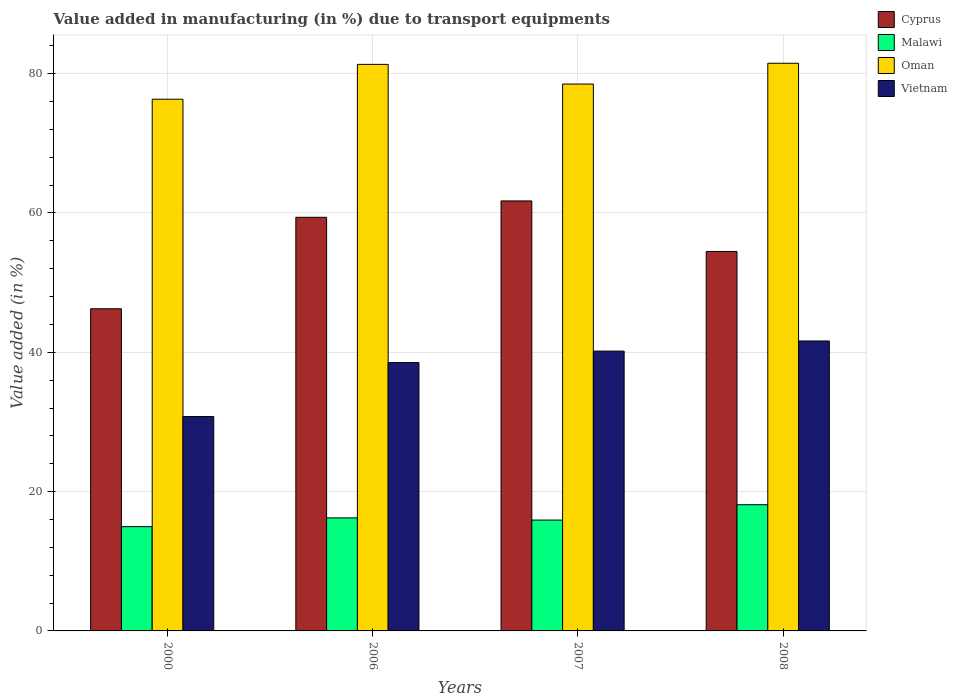Are the number of bars per tick equal to the number of legend labels?
Provide a succinct answer. Yes. How many bars are there on the 2nd tick from the left?
Keep it short and to the point. 4. How many bars are there on the 3rd tick from the right?
Make the answer very short. 4. What is the label of the 4th group of bars from the left?
Ensure brevity in your answer.  2008. In how many cases, is the number of bars for a given year not equal to the number of legend labels?
Make the answer very short. 0. What is the percentage of value added in manufacturing due to transport equipments in Vietnam in 2008?
Provide a succinct answer. 41.62. Across all years, what is the maximum percentage of value added in manufacturing due to transport equipments in Malawi?
Offer a very short reply. 18.12. Across all years, what is the minimum percentage of value added in manufacturing due to transport equipments in Malawi?
Give a very brief answer. 14.97. In which year was the percentage of value added in manufacturing due to transport equipments in Cyprus maximum?
Offer a terse response. 2007. What is the total percentage of value added in manufacturing due to transport equipments in Cyprus in the graph?
Make the answer very short. 221.82. What is the difference between the percentage of value added in manufacturing due to transport equipments in Vietnam in 2006 and that in 2007?
Make the answer very short. -1.65. What is the difference between the percentage of value added in manufacturing due to transport equipments in Malawi in 2000 and the percentage of value added in manufacturing due to transport equipments in Oman in 2008?
Keep it short and to the point. -66.52. What is the average percentage of value added in manufacturing due to transport equipments in Cyprus per year?
Make the answer very short. 55.46. In the year 2000, what is the difference between the percentage of value added in manufacturing due to transport equipments in Cyprus and percentage of value added in manufacturing due to transport equipments in Oman?
Ensure brevity in your answer.  -30.08. What is the ratio of the percentage of value added in manufacturing due to transport equipments in Malawi in 2006 to that in 2007?
Give a very brief answer. 1.02. What is the difference between the highest and the second highest percentage of value added in manufacturing due to transport equipments in Cyprus?
Offer a terse response. 2.35. What is the difference between the highest and the lowest percentage of value added in manufacturing due to transport equipments in Malawi?
Your answer should be very brief. 3.15. In how many years, is the percentage of value added in manufacturing due to transport equipments in Oman greater than the average percentage of value added in manufacturing due to transport equipments in Oman taken over all years?
Make the answer very short. 2. Is the sum of the percentage of value added in manufacturing due to transport equipments in Vietnam in 2007 and 2008 greater than the maximum percentage of value added in manufacturing due to transport equipments in Oman across all years?
Give a very brief answer. Yes. What does the 2nd bar from the left in 2006 represents?
Your response must be concise. Malawi. What does the 4th bar from the right in 2006 represents?
Offer a very short reply. Cyprus. How many years are there in the graph?
Offer a very short reply. 4. Where does the legend appear in the graph?
Ensure brevity in your answer.  Top right. How are the legend labels stacked?
Your response must be concise. Vertical. What is the title of the graph?
Provide a succinct answer. Value added in manufacturing (in %) due to transport equipments. What is the label or title of the X-axis?
Offer a very short reply. Years. What is the label or title of the Y-axis?
Provide a succinct answer. Value added (in %). What is the Value added (in %) in Cyprus in 2000?
Provide a short and direct response. 46.25. What is the Value added (in %) of Malawi in 2000?
Give a very brief answer. 14.97. What is the Value added (in %) of Oman in 2000?
Provide a short and direct response. 76.33. What is the Value added (in %) in Vietnam in 2000?
Give a very brief answer. 30.77. What is the Value added (in %) in Cyprus in 2006?
Give a very brief answer. 59.38. What is the Value added (in %) of Malawi in 2006?
Ensure brevity in your answer.  16.23. What is the Value added (in %) of Oman in 2006?
Keep it short and to the point. 81.33. What is the Value added (in %) in Vietnam in 2006?
Offer a very short reply. 38.52. What is the Value added (in %) of Cyprus in 2007?
Keep it short and to the point. 61.73. What is the Value added (in %) in Malawi in 2007?
Your response must be concise. 15.91. What is the Value added (in %) of Oman in 2007?
Your answer should be very brief. 78.51. What is the Value added (in %) in Vietnam in 2007?
Your response must be concise. 40.17. What is the Value added (in %) in Cyprus in 2008?
Your answer should be compact. 54.47. What is the Value added (in %) in Malawi in 2008?
Provide a succinct answer. 18.12. What is the Value added (in %) in Oman in 2008?
Make the answer very short. 81.49. What is the Value added (in %) in Vietnam in 2008?
Your answer should be compact. 41.62. Across all years, what is the maximum Value added (in %) of Cyprus?
Ensure brevity in your answer.  61.73. Across all years, what is the maximum Value added (in %) in Malawi?
Ensure brevity in your answer.  18.12. Across all years, what is the maximum Value added (in %) of Oman?
Offer a terse response. 81.49. Across all years, what is the maximum Value added (in %) of Vietnam?
Give a very brief answer. 41.62. Across all years, what is the minimum Value added (in %) of Cyprus?
Provide a succinct answer. 46.25. Across all years, what is the minimum Value added (in %) of Malawi?
Ensure brevity in your answer.  14.97. Across all years, what is the minimum Value added (in %) in Oman?
Your answer should be very brief. 76.33. Across all years, what is the minimum Value added (in %) of Vietnam?
Ensure brevity in your answer.  30.77. What is the total Value added (in %) of Cyprus in the graph?
Provide a short and direct response. 221.82. What is the total Value added (in %) in Malawi in the graph?
Ensure brevity in your answer.  65.23. What is the total Value added (in %) of Oman in the graph?
Make the answer very short. 317.66. What is the total Value added (in %) of Vietnam in the graph?
Make the answer very short. 151.09. What is the difference between the Value added (in %) in Cyprus in 2000 and that in 2006?
Give a very brief answer. -13.13. What is the difference between the Value added (in %) of Malawi in 2000 and that in 2006?
Give a very brief answer. -1.26. What is the difference between the Value added (in %) in Oman in 2000 and that in 2006?
Provide a succinct answer. -5. What is the difference between the Value added (in %) of Vietnam in 2000 and that in 2006?
Provide a short and direct response. -7.75. What is the difference between the Value added (in %) in Cyprus in 2000 and that in 2007?
Provide a short and direct response. -15.48. What is the difference between the Value added (in %) in Malawi in 2000 and that in 2007?
Provide a short and direct response. -0.94. What is the difference between the Value added (in %) of Oman in 2000 and that in 2007?
Give a very brief answer. -2.18. What is the difference between the Value added (in %) in Vietnam in 2000 and that in 2007?
Your answer should be very brief. -9.4. What is the difference between the Value added (in %) in Cyprus in 2000 and that in 2008?
Give a very brief answer. -8.22. What is the difference between the Value added (in %) in Malawi in 2000 and that in 2008?
Your answer should be compact. -3.15. What is the difference between the Value added (in %) in Oman in 2000 and that in 2008?
Give a very brief answer. -5.16. What is the difference between the Value added (in %) of Vietnam in 2000 and that in 2008?
Your answer should be very brief. -10.85. What is the difference between the Value added (in %) of Cyprus in 2006 and that in 2007?
Offer a terse response. -2.35. What is the difference between the Value added (in %) of Malawi in 2006 and that in 2007?
Offer a very short reply. 0.31. What is the difference between the Value added (in %) in Oman in 2006 and that in 2007?
Provide a succinct answer. 2.82. What is the difference between the Value added (in %) of Vietnam in 2006 and that in 2007?
Your answer should be compact. -1.65. What is the difference between the Value added (in %) of Cyprus in 2006 and that in 2008?
Provide a short and direct response. 4.91. What is the difference between the Value added (in %) of Malawi in 2006 and that in 2008?
Your answer should be compact. -1.89. What is the difference between the Value added (in %) of Oman in 2006 and that in 2008?
Ensure brevity in your answer.  -0.16. What is the difference between the Value added (in %) of Vietnam in 2006 and that in 2008?
Your answer should be very brief. -3.1. What is the difference between the Value added (in %) in Cyprus in 2007 and that in 2008?
Your response must be concise. 7.26. What is the difference between the Value added (in %) of Malawi in 2007 and that in 2008?
Provide a succinct answer. -2.2. What is the difference between the Value added (in %) of Oman in 2007 and that in 2008?
Offer a terse response. -2.98. What is the difference between the Value added (in %) of Vietnam in 2007 and that in 2008?
Offer a terse response. -1.45. What is the difference between the Value added (in %) in Cyprus in 2000 and the Value added (in %) in Malawi in 2006?
Your response must be concise. 30.02. What is the difference between the Value added (in %) of Cyprus in 2000 and the Value added (in %) of Oman in 2006?
Give a very brief answer. -35.08. What is the difference between the Value added (in %) in Cyprus in 2000 and the Value added (in %) in Vietnam in 2006?
Keep it short and to the point. 7.73. What is the difference between the Value added (in %) of Malawi in 2000 and the Value added (in %) of Oman in 2006?
Make the answer very short. -66.36. What is the difference between the Value added (in %) of Malawi in 2000 and the Value added (in %) of Vietnam in 2006?
Your response must be concise. -23.55. What is the difference between the Value added (in %) of Oman in 2000 and the Value added (in %) of Vietnam in 2006?
Keep it short and to the point. 37.81. What is the difference between the Value added (in %) in Cyprus in 2000 and the Value added (in %) in Malawi in 2007?
Provide a succinct answer. 30.33. What is the difference between the Value added (in %) in Cyprus in 2000 and the Value added (in %) in Oman in 2007?
Make the answer very short. -32.26. What is the difference between the Value added (in %) of Cyprus in 2000 and the Value added (in %) of Vietnam in 2007?
Ensure brevity in your answer.  6.08. What is the difference between the Value added (in %) in Malawi in 2000 and the Value added (in %) in Oman in 2007?
Provide a short and direct response. -63.54. What is the difference between the Value added (in %) of Malawi in 2000 and the Value added (in %) of Vietnam in 2007?
Provide a succinct answer. -25.2. What is the difference between the Value added (in %) in Oman in 2000 and the Value added (in %) in Vietnam in 2007?
Offer a very short reply. 36.16. What is the difference between the Value added (in %) of Cyprus in 2000 and the Value added (in %) of Malawi in 2008?
Offer a very short reply. 28.13. What is the difference between the Value added (in %) of Cyprus in 2000 and the Value added (in %) of Oman in 2008?
Make the answer very short. -35.24. What is the difference between the Value added (in %) of Cyprus in 2000 and the Value added (in %) of Vietnam in 2008?
Your answer should be very brief. 4.62. What is the difference between the Value added (in %) in Malawi in 2000 and the Value added (in %) in Oman in 2008?
Provide a succinct answer. -66.52. What is the difference between the Value added (in %) of Malawi in 2000 and the Value added (in %) of Vietnam in 2008?
Keep it short and to the point. -26.65. What is the difference between the Value added (in %) in Oman in 2000 and the Value added (in %) in Vietnam in 2008?
Your response must be concise. 34.71. What is the difference between the Value added (in %) in Cyprus in 2006 and the Value added (in %) in Malawi in 2007?
Provide a succinct answer. 43.46. What is the difference between the Value added (in %) of Cyprus in 2006 and the Value added (in %) of Oman in 2007?
Ensure brevity in your answer.  -19.13. What is the difference between the Value added (in %) of Cyprus in 2006 and the Value added (in %) of Vietnam in 2007?
Offer a terse response. 19.21. What is the difference between the Value added (in %) in Malawi in 2006 and the Value added (in %) in Oman in 2007?
Offer a terse response. -62.28. What is the difference between the Value added (in %) of Malawi in 2006 and the Value added (in %) of Vietnam in 2007?
Your response must be concise. -23.95. What is the difference between the Value added (in %) in Oman in 2006 and the Value added (in %) in Vietnam in 2007?
Offer a very short reply. 41.16. What is the difference between the Value added (in %) in Cyprus in 2006 and the Value added (in %) in Malawi in 2008?
Your answer should be very brief. 41.26. What is the difference between the Value added (in %) of Cyprus in 2006 and the Value added (in %) of Oman in 2008?
Your response must be concise. -22.11. What is the difference between the Value added (in %) of Cyprus in 2006 and the Value added (in %) of Vietnam in 2008?
Provide a short and direct response. 17.75. What is the difference between the Value added (in %) in Malawi in 2006 and the Value added (in %) in Oman in 2008?
Your answer should be very brief. -65.26. What is the difference between the Value added (in %) of Malawi in 2006 and the Value added (in %) of Vietnam in 2008?
Make the answer very short. -25.4. What is the difference between the Value added (in %) of Oman in 2006 and the Value added (in %) of Vietnam in 2008?
Make the answer very short. 39.71. What is the difference between the Value added (in %) in Cyprus in 2007 and the Value added (in %) in Malawi in 2008?
Provide a succinct answer. 43.61. What is the difference between the Value added (in %) in Cyprus in 2007 and the Value added (in %) in Oman in 2008?
Your answer should be compact. -19.76. What is the difference between the Value added (in %) of Cyprus in 2007 and the Value added (in %) of Vietnam in 2008?
Offer a terse response. 20.1. What is the difference between the Value added (in %) in Malawi in 2007 and the Value added (in %) in Oman in 2008?
Ensure brevity in your answer.  -65.58. What is the difference between the Value added (in %) in Malawi in 2007 and the Value added (in %) in Vietnam in 2008?
Your response must be concise. -25.71. What is the difference between the Value added (in %) of Oman in 2007 and the Value added (in %) of Vietnam in 2008?
Make the answer very short. 36.88. What is the average Value added (in %) of Cyprus per year?
Your response must be concise. 55.46. What is the average Value added (in %) of Malawi per year?
Ensure brevity in your answer.  16.31. What is the average Value added (in %) of Oman per year?
Provide a succinct answer. 79.41. What is the average Value added (in %) in Vietnam per year?
Give a very brief answer. 37.77. In the year 2000, what is the difference between the Value added (in %) in Cyprus and Value added (in %) in Malawi?
Your response must be concise. 31.28. In the year 2000, what is the difference between the Value added (in %) of Cyprus and Value added (in %) of Oman?
Your response must be concise. -30.08. In the year 2000, what is the difference between the Value added (in %) of Cyprus and Value added (in %) of Vietnam?
Your response must be concise. 15.47. In the year 2000, what is the difference between the Value added (in %) in Malawi and Value added (in %) in Oman?
Offer a very short reply. -61.36. In the year 2000, what is the difference between the Value added (in %) in Malawi and Value added (in %) in Vietnam?
Give a very brief answer. -15.8. In the year 2000, what is the difference between the Value added (in %) of Oman and Value added (in %) of Vietnam?
Keep it short and to the point. 45.56. In the year 2006, what is the difference between the Value added (in %) of Cyprus and Value added (in %) of Malawi?
Provide a succinct answer. 43.15. In the year 2006, what is the difference between the Value added (in %) in Cyprus and Value added (in %) in Oman?
Provide a succinct answer. -21.95. In the year 2006, what is the difference between the Value added (in %) in Cyprus and Value added (in %) in Vietnam?
Give a very brief answer. 20.86. In the year 2006, what is the difference between the Value added (in %) of Malawi and Value added (in %) of Oman?
Make the answer very short. -65.1. In the year 2006, what is the difference between the Value added (in %) of Malawi and Value added (in %) of Vietnam?
Ensure brevity in your answer.  -22.29. In the year 2006, what is the difference between the Value added (in %) in Oman and Value added (in %) in Vietnam?
Give a very brief answer. 42.81. In the year 2007, what is the difference between the Value added (in %) of Cyprus and Value added (in %) of Malawi?
Ensure brevity in your answer.  45.81. In the year 2007, what is the difference between the Value added (in %) of Cyprus and Value added (in %) of Oman?
Keep it short and to the point. -16.78. In the year 2007, what is the difference between the Value added (in %) in Cyprus and Value added (in %) in Vietnam?
Keep it short and to the point. 21.56. In the year 2007, what is the difference between the Value added (in %) of Malawi and Value added (in %) of Oman?
Provide a succinct answer. -62.59. In the year 2007, what is the difference between the Value added (in %) in Malawi and Value added (in %) in Vietnam?
Offer a terse response. -24.26. In the year 2007, what is the difference between the Value added (in %) of Oman and Value added (in %) of Vietnam?
Your answer should be compact. 38.33. In the year 2008, what is the difference between the Value added (in %) of Cyprus and Value added (in %) of Malawi?
Offer a very short reply. 36.35. In the year 2008, what is the difference between the Value added (in %) in Cyprus and Value added (in %) in Oman?
Your answer should be very brief. -27.02. In the year 2008, what is the difference between the Value added (in %) of Cyprus and Value added (in %) of Vietnam?
Give a very brief answer. 12.85. In the year 2008, what is the difference between the Value added (in %) of Malawi and Value added (in %) of Oman?
Your answer should be compact. -63.37. In the year 2008, what is the difference between the Value added (in %) of Malawi and Value added (in %) of Vietnam?
Your answer should be compact. -23.51. In the year 2008, what is the difference between the Value added (in %) in Oman and Value added (in %) in Vietnam?
Provide a short and direct response. 39.87. What is the ratio of the Value added (in %) in Cyprus in 2000 to that in 2006?
Provide a short and direct response. 0.78. What is the ratio of the Value added (in %) of Malawi in 2000 to that in 2006?
Keep it short and to the point. 0.92. What is the ratio of the Value added (in %) of Oman in 2000 to that in 2006?
Offer a terse response. 0.94. What is the ratio of the Value added (in %) of Vietnam in 2000 to that in 2006?
Your answer should be compact. 0.8. What is the ratio of the Value added (in %) in Cyprus in 2000 to that in 2007?
Give a very brief answer. 0.75. What is the ratio of the Value added (in %) of Malawi in 2000 to that in 2007?
Give a very brief answer. 0.94. What is the ratio of the Value added (in %) of Oman in 2000 to that in 2007?
Ensure brevity in your answer.  0.97. What is the ratio of the Value added (in %) of Vietnam in 2000 to that in 2007?
Provide a short and direct response. 0.77. What is the ratio of the Value added (in %) of Cyprus in 2000 to that in 2008?
Make the answer very short. 0.85. What is the ratio of the Value added (in %) of Malawi in 2000 to that in 2008?
Make the answer very short. 0.83. What is the ratio of the Value added (in %) in Oman in 2000 to that in 2008?
Provide a short and direct response. 0.94. What is the ratio of the Value added (in %) in Vietnam in 2000 to that in 2008?
Make the answer very short. 0.74. What is the ratio of the Value added (in %) in Cyprus in 2006 to that in 2007?
Make the answer very short. 0.96. What is the ratio of the Value added (in %) of Malawi in 2006 to that in 2007?
Offer a very short reply. 1.02. What is the ratio of the Value added (in %) in Oman in 2006 to that in 2007?
Ensure brevity in your answer.  1.04. What is the ratio of the Value added (in %) of Vietnam in 2006 to that in 2007?
Provide a succinct answer. 0.96. What is the ratio of the Value added (in %) in Cyprus in 2006 to that in 2008?
Make the answer very short. 1.09. What is the ratio of the Value added (in %) in Malawi in 2006 to that in 2008?
Your answer should be compact. 0.9. What is the ratio of the Value added (in %) in Oman in 2006 to that in 2008?
Keep it short and to the point. 1. What is the ratio of the Value added (in %) in Vietnam in 2006 to that in 2008?
Give a very brief answer. 0.93. What is the ratio of the Value added (in %) of Cyprus in 2007 to that in 2008?
Your answer should be very brief. 1.13. What is the ratio of the Value added (in %) in Malawi in 2007 to that in 2008?
Provide a short and direct response. 0.88. What is the ratio of the Value added (in %) in Oman in 2007 to that in 2008?
Ensure brevity in your answer.  0.96. What is the ratio of the Value added (in %) in Vietnam in 2007 to that in 2008?
Make the answer very short. 0.97. What is the difference between the highest and the second highest Value added (in %) in Cyprus?
Make the answer very short. 2.35. What is the difference between the highest and the second highest Value added (in %) in Malawi?
Offer a terse response. 1.89. What is the difference between the highest and the second highest Value added (in %) of Oman?
Offer a terse response. 0.16. What is the difference between the highest and the second highest Value added (in %) in Vietnam?
Provide a succinct answer. 1.45. What is the difference between the highest and the lowest Value added (in %) of Cyprus?
Give a very brief answer. 15.48. What is the difference between the highest and the lowest Value added (in %) of Malawi?
Offer a terse response. 3.15. What is the difference between the highest and the lowest Value added (in %) in Oman?
Keep it short and to the point. 5.16. What is the difference between the highest and the lowest Value added (in %) of Vietnam?
Provide a short and direct response. 10.85. 